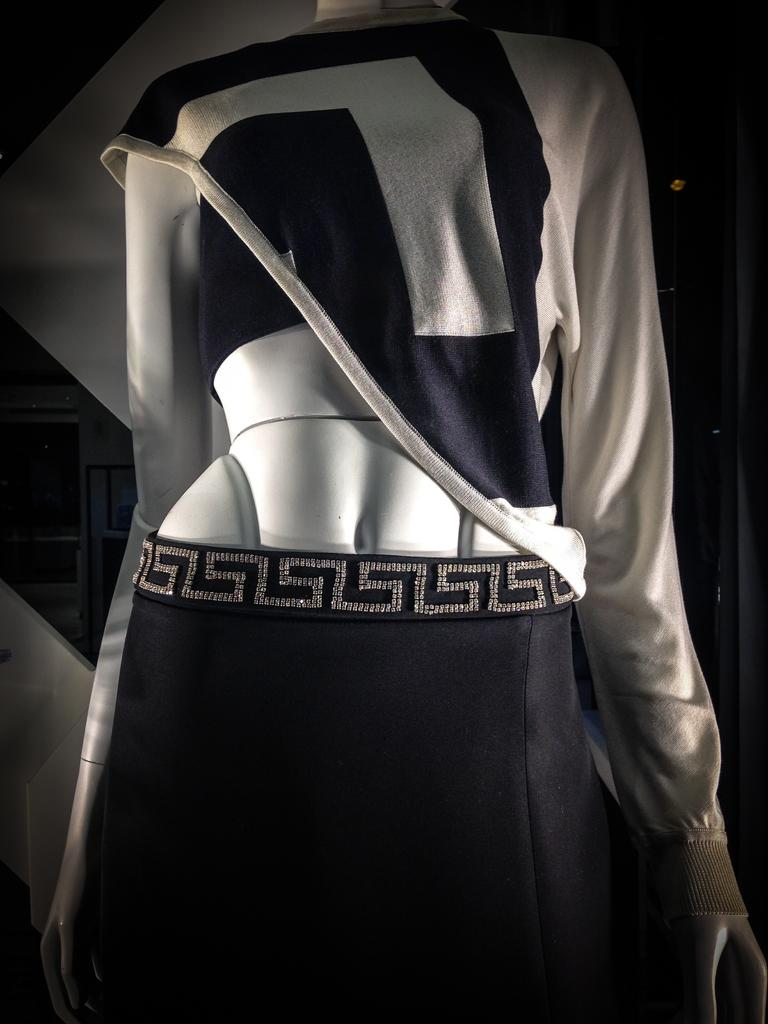What is the main subject of the image? There is a mannequin in the image. What is the mannequin wearing? The mannequin is wearing clothes. Can you describe the background of the image? The background of the image is dark. How many grapes are on the mannequin's head in the image? There are no grapes present in the image, and the mannequin is not wearing any on its head. 